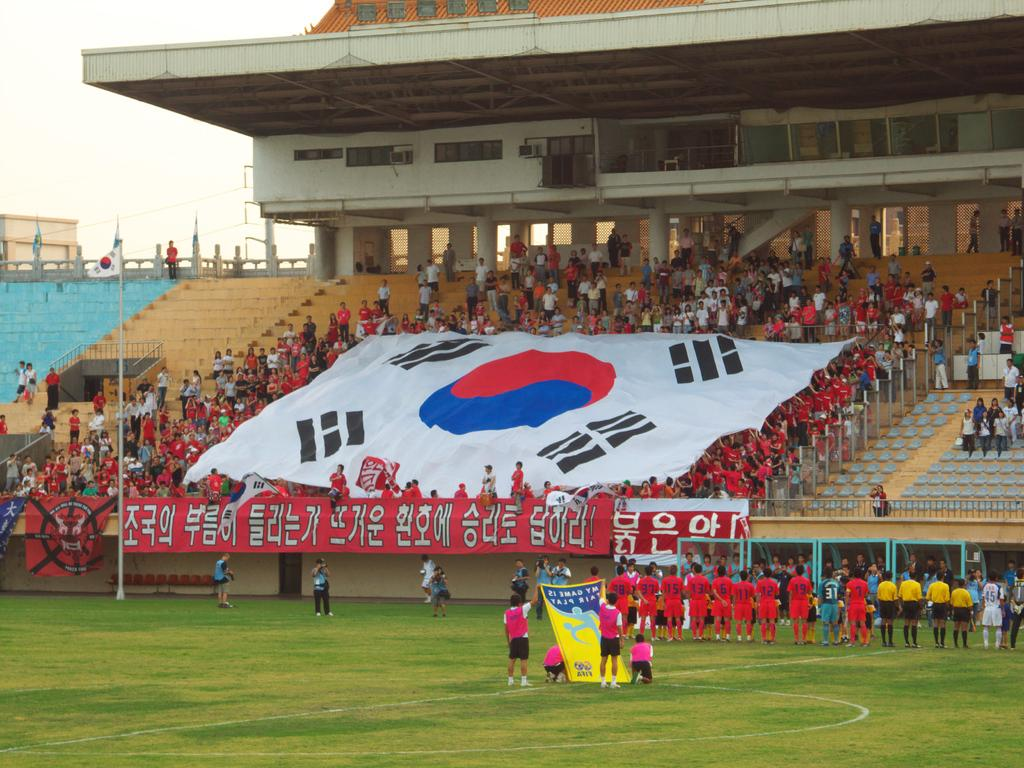How many people are in the image? There is a group of people in the image, but the exact number is not specified. What architectural feature can be seen in the image? There are stairs in the image. What decorative elements are present in the image? Banners are present in the image. What type of openings can be seen in the image? There are windows in the image. What material is visible in the image? Cloth is visible in the image. What type of vegetation is present in the image? Grass is present in the image. What symbolic object is present in the image? There is a flag in the image. What is visible at the top of the image? The sky is visible at the top of the image. How does the cushion help the people in the image express their anger? There is no mention of a cushion or anger in the image. How does the cloth twist around the stairs in the image? The cloth does not twist around the stairs in the image; it is simply visible. 